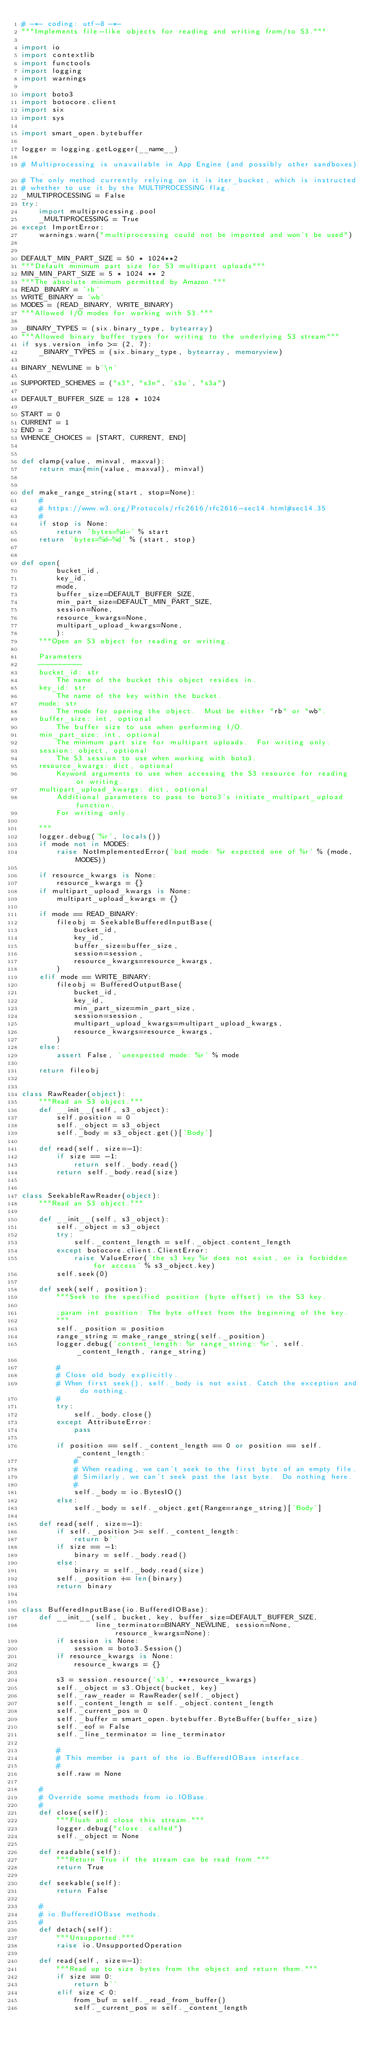<code> <loc_0><loc_0><loc_500><loc_500><_Python_># -*- coding: utf-8 -*-
"""Implements file-like objects for reading and writing from/to S3."""

import io
import contextlib
import functools
import logging
import warnings

import boto3
import botocore.client
import six
import sys

import smart_open.bytebuffer

logger = logging.getLogger(__name__)

# Multiprocessing is unavailable in App Engine (and possibly other sandboxes).
# The only method currently relying on it is iter_bucket, which is instructed
# whether to use it by the MULTIPROCESSING flag.
_MULTIPROCESSING = False
try:
    import multiprocessing.pool
    _MULTIPROCESSING = True
except ImportError:
    warnings.warn("multiprocessing could not be imported and won't be used")


DEFAULT_MIN_PART_SIZE = 50 * 1024**2
"""Default minimum part size for S3 multipart uploads"""
MIN_MIN_PART_SIZE = 5 * 1024 ** 2
"""The absolute minimum permitted by Amazon."""
READ_BINARY = 'rb'
WRITE_BINARY = 'wb'
MODES = (READ_BINARY, WRITE_BINARY)
"""Allowed I/O modes for working with S3."""

_BINARY_TYPES = (six.binary_type, bytearray)
"""Allowed binary buffer types for writing to the underlying S3 stream"""
if sys.version_info >= (2, 7):
    _BINARY_TYPES = (six.binary_type, bytearray, memoryview)

BINARY_NEWLINE = b'\n'

SUPPORTED_SCHEMES = ("s3", "s3n", 's3u', "s3a")

DEFAULT_BUFFER_SIZE = 128 * 1024

START = 0
CURRENT = 1
END = 2
WHENCE_CHOICES = [START, CURRENT, END]


def clamp(value, minval, maxval):
    return max(min(value, maxval), minval)


def make_range_string(start, stop=None):
    #
    # https://www.w3.org/Protocols/rfc2616/rfc2616-sec14.html#sec14.35
    #
    if stop is None:
        return 'bytes=%d-' % start
    return 'bytes=%d-%d' % (start, stop)


def open(
        bucket_id,
        key_id,
        mode,
        buffer_size=DEFAULT_BUFFER_SIZE,
        min_part_size=DEFAULT_MIN_PART_SIZE,
        session=None,
        resource_kwargs=None,
        multipart_upload_kwargs=None,
        ):
    """Open an S3 object for reading or writing.

    Parameters
    ----------
    bucket_id: str
        The name of the bucket this object resides in.
    key_id: str
        The name of the key within the bucket.
    mode: str
        The mode for opening the object.  Must be either "rb" or "wb".
    buffer_size: int, optional
        The buffer size to use when performing I/O.
    min_part_size: int, optional
        The minimum part size for multipart uploads.  For writing only.
    session: object, optional
        The S3 session to use when working with boto3.
    resource_kwargs: dict, optional
        Keyword arguments to use when accessing the S3 resource for reading or writing.
    multipart_upload_kwargs: dict, optional
        Additional parameters to pass to boto3's initiate_multipart_upload function.
        For writing only.

    """
    logger.debug('%r', locals())
    if mode not in MODES:
        raise NotImplementedError('bad mode: %r expected one of %r' % (mode, MODES))

    if resource_kwargs is None:
        resource_kwargs = {}
    if multipart_upload_kwargs is None:
        multipart_upload_kwargs = {}

    if mode == READ_BINARY:
        fileobj = SeekableBufferedInputBase(
            bucket_id,
            key_id,
            buffer_size=buffer_size,
            session=session,
            resource_kwargs=resource_kwargs,
        )
    elif mode == WRITE_BINARY:
        fileobj = BufferedOutputBase(
            bucket_id,
            key_id,
            min_part_size=min_part_size,
            session=session,
            multipart_upload_kwargs=multipart_upload_kwargs,
            resource_kwargs=resource_kwargs,
        )
    else:
        assert False, 'unexpected mode: %r' % mode

    return fileobj


class RawReader(object):
    """Read an S3 object."""
    def __init__(self, s3_object):
        self.position = 0
        self._object = s3_object
        self._body = s3_object.get()['Body']

    def read(self, size=-1):
        if size == -1:
            return self._body.read()
        return self._body.read(size)


class SeekableRawReader(object):
    """Read an S3 object."""

    def __init__(self, s3_object):
        self._object = s3_object
        try:
            self._content_length = self._object.content_length
        except botocore.client.ClientError:
            raise ValueError('the s3 key %r does not exist, or is forbidden for access' % s3_object.key)
        self.seek(0)

    def seek(self, position):
        """Seek to the specified position (byte offset) in the S3 key.

        :param int position: The byte offset from the beginning of the key.
        """
        self._position = position
        range_string = make_range_string(self._position)
        logger.debug('content_length: %r range_string: %r', self._content_length, range_string)

        #
        # Close old body explicitly.
        # When first seek(), self._body is not exist. Catch the exception and do nothing.
        #
        try:
            self._body.close()
        except AttributeError:
            pass

        if position == self._content_length == 0 or position == self._content_length:
            #
            # When reading, we can't seek to the first byte of an empty file.
            # Similarly, we can't seek past the last byte.  Do nothing here.
            #
            self._body = io.BytesIO()
        else:
            self._body = self._object.get(Range=range_string)['Body']

    def read(self, size=-1):
        if self._position >= self._content_length:
            return b''
        if size == -1:
            binary = self._body.read()
        else:
            binary = self._body.read(size)
        self._position += len(binary)
        return binary


class BufferedInputBase(io.BufferedIOBase):
    def __init__(self, bucket, key, buffer_size=DEFAULT_BUFFER_SIZE,
                 line_terminator=BINARY_NEWLINE, session=None, resource_kwargs=None):
        if session is None:
            session = boto3.Session()
        if resource_kwargs is None:
            resource_kwargs = {}

        s3 = session.resource('s3', **resource_kwargs)
        self._object = s3.Object(bucket, key)
        self._raw_reader = RawReader(self._object)
        self._content_length = self._object.content_length
        self._current_pos = 0
        self._buffer = smart_open.bytebuffer.ByteBuffer(buffer_size)
        self._eof = False
        self._line_terminator = line_terminator

        #
        # This member is part of the io.BufferedIOBase interface.
        #
        self.raw = None

    #
    # Override some methods from io.IOBase.
    #
    def close(self):
        """Flush and close this stream."""
        logger.debug("close: called")
        self._object = None

    def readable(self):
        """Return True if the stream can be read from."""
        return True

    def seekable(self):
        return False

    #
    # io.BufferedIOBase methods.
    #
    def detach(self):
        """Unsupported."""
        raise io.UnsupportedOperation

    def read(self, size=-1):
        """Read up to size bytes from the object and return them."""
        if size == 0:
            return b''
        elif size < 0:
            from_buf = self._read_from_buffer()
            self._current_pos = self._content_length</code> 